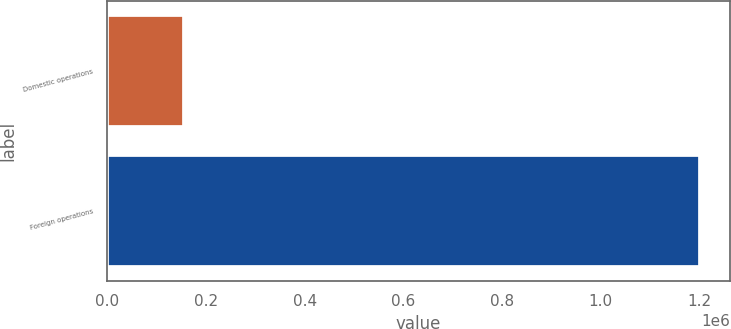Convert chart to OTSL. <chart><loc_0><loc_0><loc_500><loc_500><bar_chart><fcel>Domestic operations<fcel>Foreign operations<nl><fcel>155296<fcel>1.20154e+06<nl></chart> 